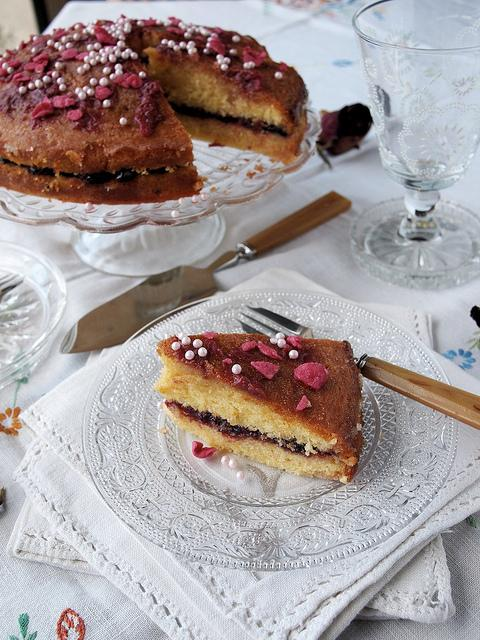What is the filling made of? Please explain your reasoning. fruit. Fruit pieces can be seen on top of the cake. 